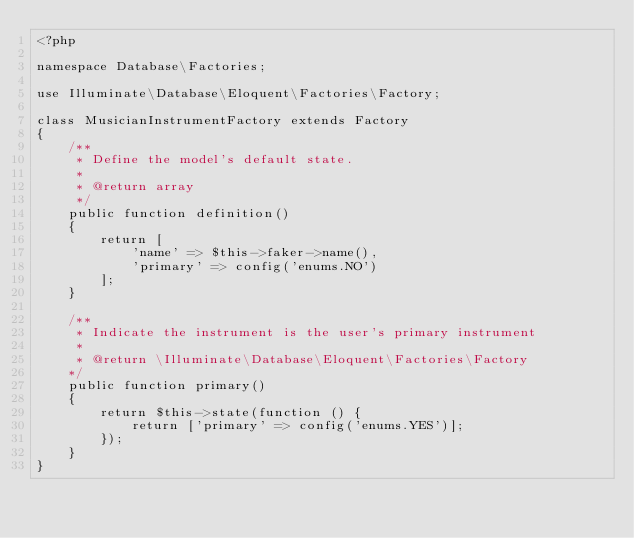<code> <loc_0><loc_0><loc_500><loc_500><_PHP_><?php

namespace Database\Factories;

use Illuminate\Database\Eloquent\Factories\Factory;

class MusicianInstrumentFactory extends Factory
{
    /**
     * Define the model's default state.
     *
     * @return array
     */
    public function definition()
    {
        return [
            'name' => $this->faker->name(),
            'primary' => config('enums.NO')
        ];
    }

    /**
     * Indicate the instrument is the user's primary instrument
     *
     * @return \Illuminate\Database\Eloquent\Factories\Factory
    */
    public function primary()
    {
        return $this->state(function () {
            return ['primary' => config('enums.YES')];
        });
    }
}
</code> 